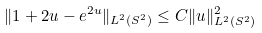<formula> <loc_0><loc_0><loc_500><loc_500>\| 1 + 2 u - e ^ { 2 u } \| _ { L ^ { 2 } ( S ^ { 2 } ) } \leq C \| u \| ^ { 2 } _ { L ^ { 2 } ( S ^ { 2 } ) }</formula> 